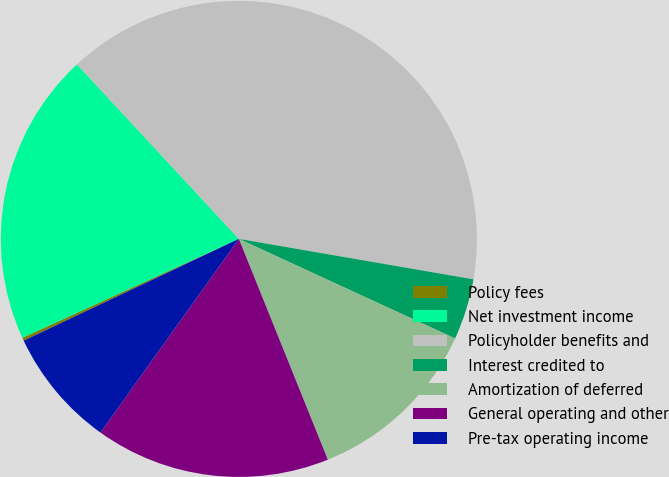Convert chart. <chart><loc_0><loc_0><loc_500><loc_500><pie_chart><fcel>Policy fees<fcel>Net investment income<fcel>Policyholder benefits and<fcel>Interest credited to<fcel>Amortization of deferred<fcel>General operating and other<fcel>Pre-tax operating income<nl><fcel>0.21%<fcel>19.91%<fcel>39.61%<fcel>4.15%<fcel>12.03%<fcel>15.97%<fcel>8.09%<nl></chart> 